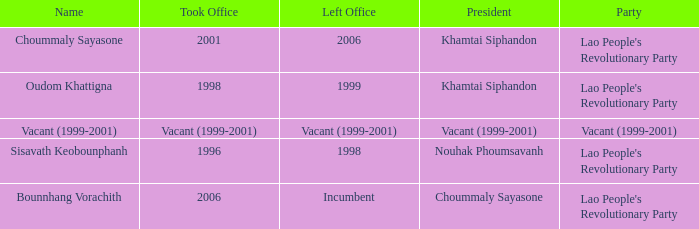What is Party, when Name is Oudom Khattigna? Lao People's Revolutionary Party. 